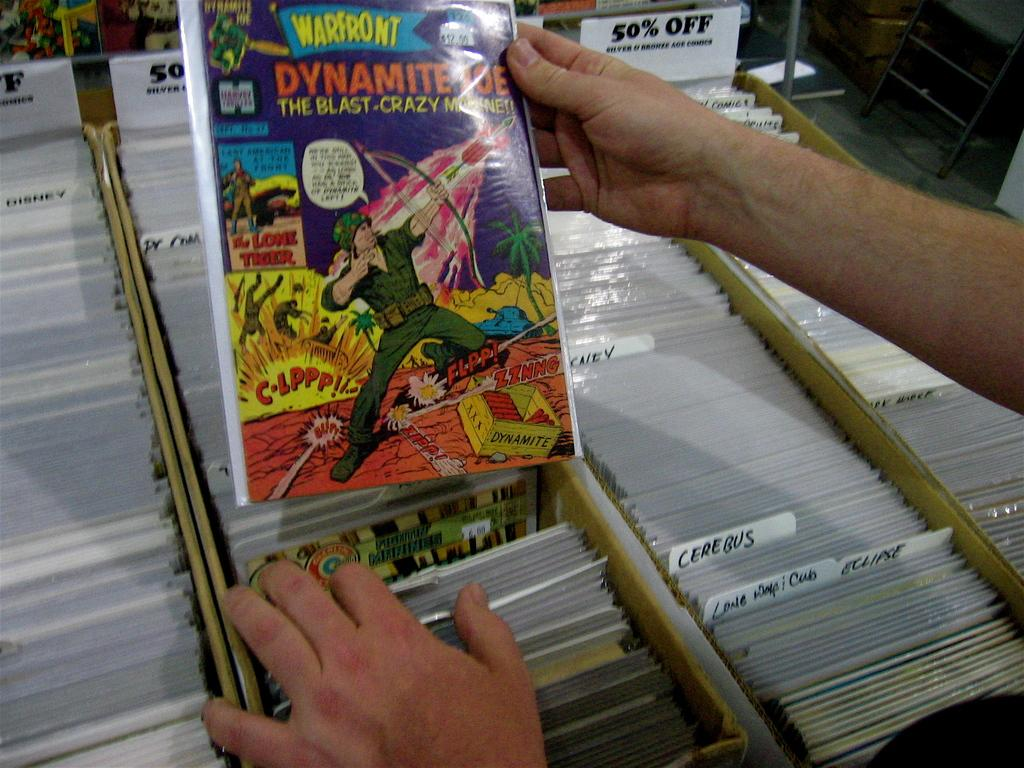What is the main subject of the image? There is a person in the image. What is the person holding in his hand? The person is holding a cartoon story label in his hand. What else can be seen in the image besides the person? There are many other labels on the shelf in the image. Can you tell me how many balls are visible in the image? There are no balls present in the image. What type of event is taking place in the image? There is no event depicted in the image; it simply shows a person holding a cartoon story label and other labels on a shelf. 